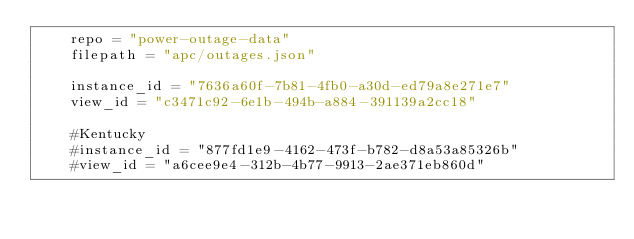Convert code to text. <code><loc_0><loc_0><loc_500><loc_500><_Python_>    repo = "power-outage-data"
    filepath = "apc/outages.json"

    instance_id = "7636a60f-7b81-4fb0-a30d-ed79a8e271e7"
    view_id = "c3471c92-6e1b-494b-a884-391139a2cc18"
   
    #Kentucky 
    #instance_id = "877fd1e9-4162-473f-b782-d8a53a85326b" 
    #view_id = "a6cee9e4-312b-4b77-9913-2ae371eb860d"
</code> 